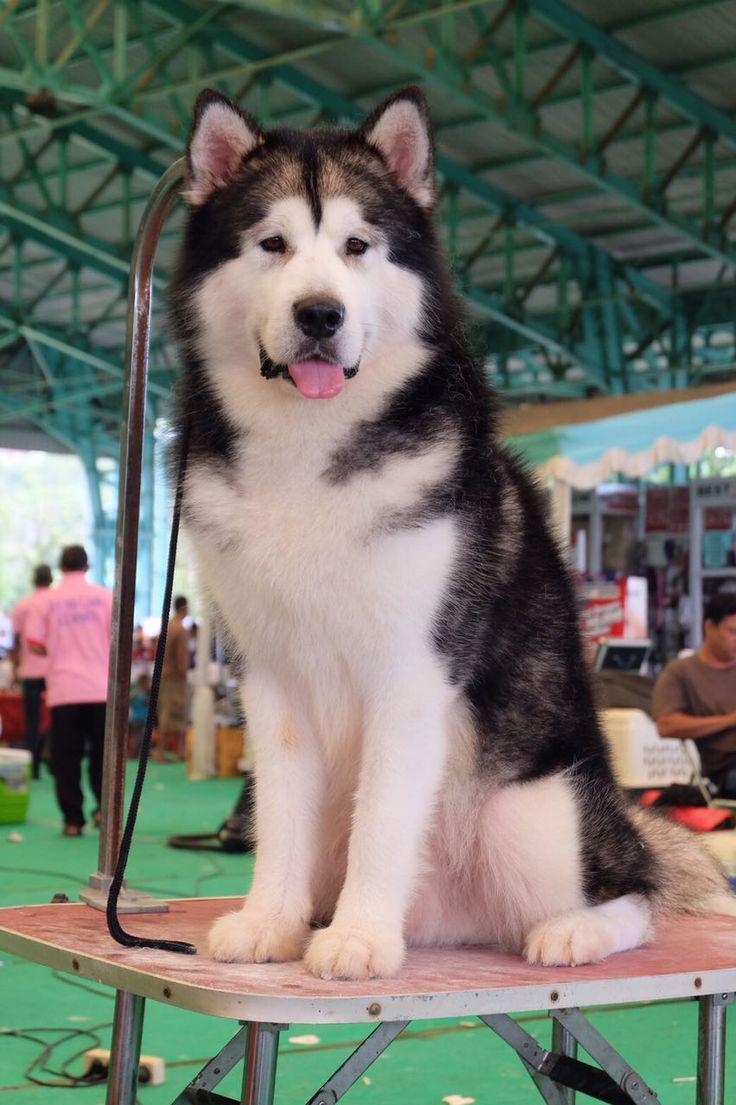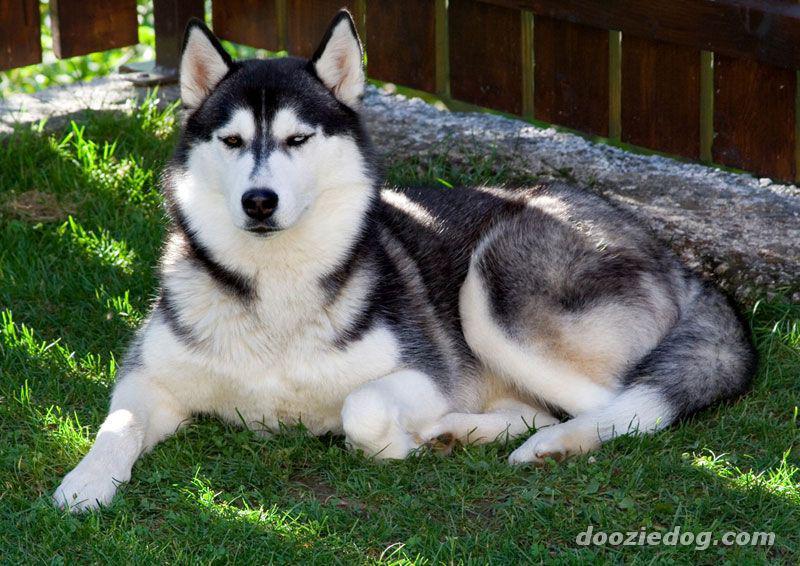The first image is the image on the left, the second image is the image on the right. For the images displayed, is the sentence "Three or more mammals are visible." factually correct? Answer yes or no. Yes. 